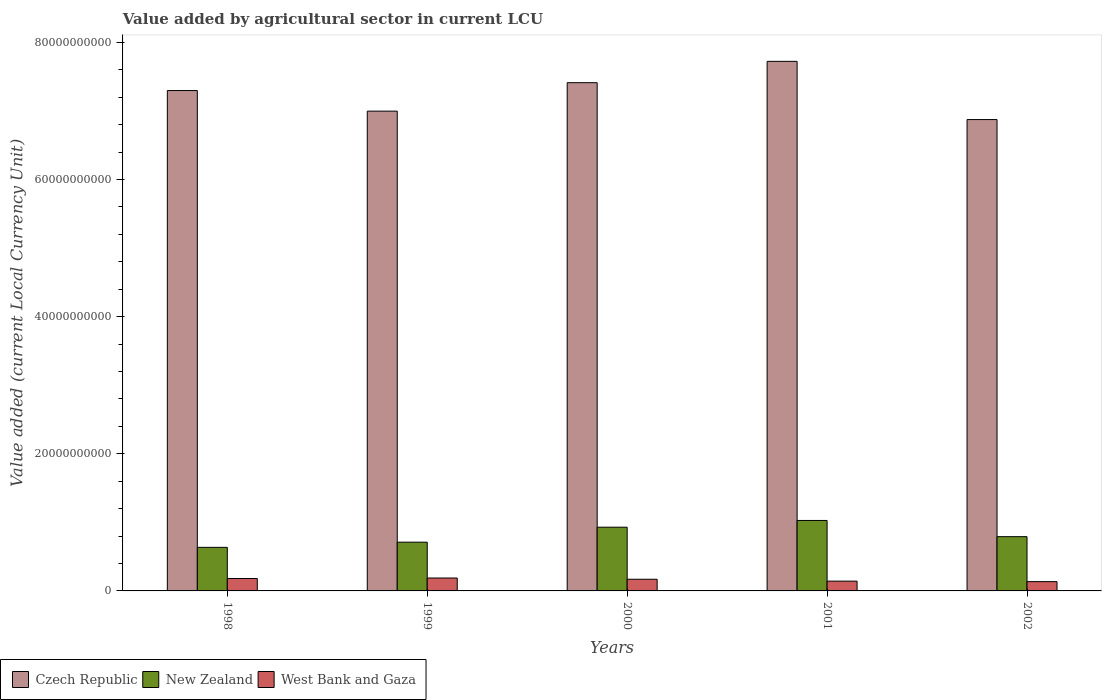Are the number of bars on each tick of the X-axis equal?
Provide a short and direct response. Yes. How many bars are there on the 3rd tick from the left?
Ensure brevity in your answer.  3. What is the label of the 1st group of bars from the left?
Keep it short and to the point. 1998. In how many cases, is the number of bars for a given year not equal to the number of legend labels?
Your answer should be compact. 0. What is the value added by agricultural sector in New Zealand in 2002?
Your answer should be very brief. 7.91e+09. Across all years, what is the maximum value added by agricultural sector in New Zealand?
Keep it short and to the point. 1.03e+1. Across all years, what is the minimum value added by agricultural sector in West Bank and Gaza?
Provide a short and direct response. 1.35e+09. What is the total value added by agricultural sector in Czech Republic in the graph?
Offer a very short reply. 3.63e+11. What is the difference between the value added by agricultural sector in Czech Republic in 1998 and that in 2002?
Offer a very short reply. 4.23e+09. What is the difference between the value added by agricultural sector in West Bank and Gaza in 2000 and the value added by agricultural sector in Czech Republic in 2002?
Provide a succinct answer. -6.70e+1. What is the average value added by agricultural sector in West Bank and Gaza per year?
Your response must be concise. 1.64e+09. In the year 2002, what is the difference between the value added by agricultural sector in New Zealand and value added by agricultural sector in Czech Republic?
Provide a succinct answer. -6.08e+1. What is the ratio of the value added by agricultural sector in New Zealand in 2000 to that in 2002?
Keep it short and to the point. 1.17. Is the difference between the value added by agricultural sector in New Zealand in 2000 and 2001 greater than the difference between the value added by agricultural sector in Czech Republic in 2000 and 2001?
Give a very brief answer. Yes. What is the difference between the highest and the second highest value added by agricultural sector in Czech Republic?
Give a very brief answer. 3.11e+09. What is the difference between the highest and the lowest value added by agricultural sector in New Zealand?
Your answer should be very brief. 3.92e+09. In how many years, is the value added by agricultural sector in Czech Republic greater than the average value added by agricultural sector in Czech Republic taken over all years?
Ensure brevity in your answer.  3. What does the 2nd bar from the left in 1998 represents?
Your response must be concise. New Zealand. What does the 3rd bar from the right in 2000 represents?
Give a very brief answer. Czech Republic. Is it the case that in every year, the sum of the value added by agricultural sector in Czech Republic and value added by agricultural sector in West Bank and Gaza is greater than the value added by agricultural sector in New Zealand?
Provide a short and direct response. Yes. How many bars are there?
Make the answer very short. 15. Are the values on the major ticks of Y-axis written in scientific E-notation?
Keep it short and to the point. No. Does the graph contain any zero values?
Keep it short and to the point. No. How many legend labels are there?
Your response must be concise. 3. What is the title of the graph?
Make the answer very short. Value added by agricultural sector in current LCU. Does "Iran" appear as one of the legend labels in the graph?
Offer a very short reply. No. What is the label or title of the Y-axis?
Your answer should be very brief. Value added (current Local Currency Unit). What is the Value added (current Local Currency Unit) in Czech Republic in 1998?
Provide a short and direct response. 7.30e+1. What is the Value added (current Local Currency Unit) in New Zealand in 1998?
Keep it short and to the point. 6.35e+09. What is the Value added (current Local Currency Unit) of West Bank and Gaza in 1998?
Your response must be concise. 1.81e+09. What is the Value added (current Local Currency Unit) of Czech Republic in 1999?
Make the answer very short. 7.00e+1. What is the Value added (current Local Currency Unit) of New Zealand in 1999?
Your answer should be compact. 7.11e+09. What is the Value added (current Local Currency Unit) of West Bank and Gaza in 1999?
Provide a short and direct response. 1.88e+09. What is the Value added (current Local Currency Unit) of Czech Republic in 2000?
Make the answer very short. 7.41e+1. What is the Value added (current Local Currency Unit) of New Zealand in 2000?
Provide a short and direct response. 9.29e+09. What is the Value added (current Local Currency Unit) of West Bank and Gaza in 2000?
Offer a very short reply. 1.70e+09. What is the Value added (current Local Currency Unit) in Czech Republic in 2001?
Provide a short and direct response. 7.72e+1. What is the Value added (current Local Currency Unit) in New Zealand in 2001?
Make the answer very short. 1.03e+1. What is the Value added (current Local Currency Unit) in West Bank and Gaza in 2001?
Offer a terse response. 1.43e+09. What is the Value added (current Local Currency Unit) of Czech Republic in 2002?
Keep it short and to the point. 6.87e+1. What is the Value added (current Local Currency Unit) in New Zealand in 2002?
Provide a short and direct response. 7.91e+09. What is the Value added (current Local Currency Unit) in West Bank and Gaza in 2002?
Provide a succinct answer. 1.35e+09. Across all years, what is the maximum Value added (current Local Currency Unit) in Czech Republic?
Keep it short and to the point. 7.72e+1. Across all years, what is the maximum Value added (current Local Currency Unit) of New Zealand?
Make the answer very short. 1.03e+1. Across all years, what is the maximum Value added (current Local Currency Unit) of West Bank and Gaza?
Your response must be concise. 1.88e+09. Across all years, what is the minimum Value added (current Local Currency Unit) in Czech Republic?
Provide a succinct answer. 6.87e+1. Across all years, what is the minimum Value added (current Local Currency Unit) in New Zealand?
Provide a short and direct response. 6.35e+09. Across all years, what is the minimum Value added (current Local Currency Unit) in West Bank and Gaza?
Give a very brief answer. 1.35e+09. What is the total Value added (current Local Currency Unit) in Czech Republic in the graph?
Ensure brevity in your answer.  3.63e+11. What is the total Value added (current Local Currency Unit) of New Zealand in the graph?
Give a very brief answer. 4.09e+1. What is the total Value added (current Local Currency Unit) in West Bank and Gaza in the graph?
Make the answer very short. 8.18e+09. What is the difference between the Value added (current Local Currency Unit) of Czech Republic in 1998 and that in 1999?
Your answer should be compact. 3.00e+09. What is the difference between the Value added (current Local Currency Unit) of New Zealand in 1998 and that in 1999?
Make the answer very short. -7.54e+08. What is the difference between the Value added (current Local Currency Unit) of West Bank and Gaza in 1998 and that in 1999?
Provide a short and direct response. -7.26e+07. What is the difference between the Value added (current Local Currency Unit) of Czech Republic in 1998 and that in 2000?
Your answer should be very brief. -1.15e+09. What is the difference between the Value added (current Local Currency Unit) in New Zealand in 1998 and that in 2000?
Provide a short and direct response. -2.94e+09. What is the difference between the Value added (current Local Currency Unit) of West Bank and Gaza in 1998 and that in 2000?
Give a very brief answer. 1.07e+08. What is the difference between the Value added (current Local Currency Unit) in Czech Republic in 1998 and that in 2001?
Your answer should be compact. -4.26e+09. What is the difference between the Value added (current Local Currency Unit) in New Zealand in 1998 and that in 2001?
Your answer should be compact. -3.92e+09. What is the difference between the Value added (current Local Currency Unit) in West Bank and Gaza in 1998 and that in 2001?
Your response must be concise. 3.83e+08. What is the difference between the Value added (current Local Currency Unit) of Czech Republic in 1998 and that in 2002?
Make the answer very short. 4.23e+09. What is the difference between the Value added (current Local Currency Unit) in New Zealand in 1998 and that in 2002?
Make the answer very short. -1.56e+09. What is the difference between the Value added (current Local Currency Unit) of West Bank and Gaza in 1998 and that in 2002?
Your response must be concise. 4.57e+08. What is the difference between the Value added (current Local Currency Unit) of Czech Republic in 1999 and that in 2000?
Provide a succinct answer. -4.15e+09. What is the difference between the Value added (current Local Currency Unit) in New Zealand in 1999 and that in 2000?
Your answer should be very brief. -2.18e+09. What is the difference between the Value added (current Local Currency Unit) of West Bank and Gaza in 1999 and that in 2000?
Offer a very short reply. 1.79e+08. What is the difference between the Value added (current Local Currency Unit) of Czech Republic in 1999 and that in 2001?
Ensure brevity in your answer.  -7.26e+09. What is the difference between the Value added (current Local Currency Unit) of New Zealand in 1999 and that in 2001?
Make the answer very short. -3.17e+09. What is the difference between the Value added (current Local Currency Unit) of West Bank and Gaza in 1999 and that in 2001?
Offer a very short reply. 4.55e+08. What is the difference between the Value added (current Local Currency Unit) in Czech Republic in 1999 and that in 2002?
Give a very brief answer. 1.23e+09. What is the difference between the Value added (current Local Currency Unit) of New Zealand in 1999 and that in 2002?
Ensure brevity in your answer.  -8.06e+08. What is the difference between the Value added (current Local Currency Unit) of West Bank and Gaza in 1999 and that in 2002?
Your response must be concise. 5.30e+08. What is the difference between the Value added (current Local Currency Unit) in Czech Republic in 2000 and that in 2001?
Your answer should be very brief. -3.11e+09. What is the difference between the Value added (current Local Currency Unit) of New Zealand in 2000 and that in 2001?
Provide a short and direct response. -9.82e+08. What is the difference between the Value added (current Local Currency Unit) in West Bank and Gaza in 2000 and that in 2001?
Offer a terse response. 2.76e+08. What is the difference between the Value added (current Local Currency Unit) of Czech Republic in 2000 and that in 2002?
Provide a succinct answer. 5.38e+09. What is the difference between the Value added (current Local Currency Unit) of New Zealand in 2000 and that in 2002?
Give a very brief answer. 1.38e+09. What is the difference between the Value added (current Local Currency Unit) of West Bank and Gaza in 2000 and that in 2002?
Provide a succinct answer. 3.50e+08. What is the difference between the Value added (current Local Currency Unit) in Czech Republic in 2001 and that in 2002?
Offer a terse response. 8.49e+09. What is the difference between the Value added (current Local Currency Unit) in New Zealand in 2001 and that in 2002?
Your answer should be compact. 2.36e+09. What is the difference between the Value added (current Local Currency Unit) in West Bank and Gaza in 2001 and that in 2002?
Your response must be concise. 7.43e+07. What is the difference between the Value added (current Local Currency Unit) of Czech Republic in 1998 and the Value added (current Local Currency Unit) of New Zealand in 1999?
Provide a short and direct response. 6.59e+1. What is the difference between the Value added (current Local Currency Unit) in Czech Republic in 1998 and the Value added (current Local Currency Unit) in West Bank and Gaza in 1999?
Give a very brief answer. 7.11e+1. What is the difference between the Value added (current Local Currency Unit) of New Zealand in 1998 and the Value added (current Local Currency Unit) of West Bank and Gaza in 1999?
Give a very brief answer. 4.47e+09. What is the difference between the Value added (current Local Currency Unit) in Czech Republic in 1998 and the Value added (current Local Currency Unit) in New Zealand in 2000?
Your response must be concise. 6.37e+1. What is the difference between the Value added (current Local Currency Unit) in Czech Republic in 1998 and the Value added (current Local Currency Unit) in West Bank and Gaza in 2000?
Offer a very short reply. 7.13e+1. What is the difference between the Value added (current Local Currency Unit) in New Zealand in 1998 and the Value added (current Local Currency Unit) in West Bank and Gaza in 2000?
Offer a terse response. 4.65e+09. What is the difference between the Value added (current Local Currency Unit) in Czech Republic in 1998 and the Value added (current Local Currency Unit) in New Zealand in 2001?
Offer a terse response. 6.27e+1. What is the difference between the Value added (current Local Currency Unit) of Czech Republic in 1998 and the Value added (current Local Currency Unit) of West Bank and Gaza in 2001?
Ensure brevity in your answer.  7.15e+1. What is the difference between the Value added (current Local Currency Unit) of New Zealand in 1998 and the Value added (current Local Currency Unit) of West Bank and Gaza in 2001?
Offer a very short reply. 4.92e+09. What is the difference between the Value added (current Local Currency Unit) in Czech Republic in 1998 and the Value added (current Local Currency Unit) in New Zealand in 2002?
Provide a short and direct response. 6.50e+1. What is the difference between the Value added (current Local Currency Unit) in Czech Republic in 1998 and the Value added (current Local Currency Unit) in West Bank and Gaza in 2002?
Your response must be concise. 7.16e+1. What is the difference between the Value added (current Local Currency Unit) of New Zealand in 1998 and the Value added (current Local Currency Unit) of West Bank and Gaza in 2002?
Offer a very short reply. 5.00e+09. What is the difference between the Value added (current Local Currency Unit) in Czech Republic in 1999 and the Value added (current Local Currency Unit) in New Zealand in 2000?
Give a very brief answer. 6.07e+1. What is the difference between the Value added (current Local Currency Unit) of Czech Republic in 1999 and the Value added (current Local Currency Unit) of West Bank and Gaza in 2000?
Provide a short and direct response. 6.83e+1. What is the difference between the Value added (current Local Currency Unit) in New Zealand in 1999 and the Value added (current Local Currency Unit) in West Bank and Gaza in 2000?
Provide a succinct answer. 5.40e+09. What is the difference between the Value added (current Local Currency Unit) of Czech Republic in 1999 and the Value added (current Local Currency Unit) of New Zealand in 2001?
Your answer should be very brief. 5.97e+1. What is the difference between the Value added (current Local Currency Unit) in Czech Republic in 1999 and the Value added (current Local Currency Unit) in West Bank and Gaza in 2001?
Offer a very short reply. 6.85e+1. What is the difference between the Value added (current Local Currency Unit) in New Zealand in 1999 and the Value added (current Local Currency Unit) in West Bank and Gaza in 2001?
Your response must be concise. 5.68e+09. What is the difference between the Value added (current Local Currency Unit) in Czech Republic in 1999 and the Value added (current Local Currency Unit) in New Zealand in 2002?
Your answer should be very brief. 6.20e+1. What is the difference between the Value added (current Local Currency Unit) of Czech Republic in 1999 and the Value added (current Local Currency Unit) of West Bank and Gaza in 2002?
Make the answer very short. 6.86e+1. What is the difference between the Value added (current Local Currency Unit) in New Zealand in 1999 and the Value added (current Local Currency Unit) in West Bank and Gaza in 2002?
Make the answer very short. 5.75e+09. What is the difference between the Value added (current Local Currency Unit) of Czech Republic in 2000 and the Value added (current Local Currency Unit) of New Zealand in 2001?
Make the answer very short. 6.38e+1. What is the difference between the Value added (current Local Currency Unit) of Czech Republic in 2000 and the Value added (current Local Currency Unit) of West Bank and Gaza in 2001?
Your answer should be compact. 7.27e+1. What is the difference between the Value added (current Local Currency Unit) in New Zealand in 2000 and the Value added (current Local Currency Unit) in West Bank and Gaza in 2001?
Your answer should be compact. 7.86e+09. What is the difference between the Value added (current Local Currency Unit) of Czech Republic in 2000 and the Value added (current Local Currency Unit) of New Zealand in 2002?
Offer a terse response. 6.62e+1. What is the difference between the Value added (current Local Currency Unit) of Czech Republic in 2000 and the Value added (current Local Currency Unit) of West Bank and Gaza in 2002?
Provide a short and direct response. 7.28e+1. What is the difference between the Value added (current Local Currency Unit) of New Zealand in 2000 and the Value added (current Local Currency Unit) of West Bank and Gaza in 2002?
Provide a short and direct response. 7.94e+09. What is the difference between the Value added (current Local Currency Unit) of Czech Republic in 2001 and the Value added (current Local Currency Unit) of New Zealand in 2002?
Give a very brief answer. 6.93e+1. What is the difference between the Value added (current Local Currency Unit) of Czech Republic in 2001 and the Value added (current Local Currency Unit) of West Bank and Gaza in 2002?
Your response must be concise. 7.59e+1. What is the difference between the Value added (current Local Currency Unit) of New Zealand in 2001 and the Value added (current Local Currency Unit) of West Bank and Gaza in 2002?
Offer a terse response. 8.92e+09. What is the average Value added (current Local Currency Unit) in Czech Republic per year?
Make the answer very short. 7.26e+1. What is the average Value added (current Local Currency Unit) of New Zealand per year?
Ensure brevity in your answer.  8.19e+09. What is the average Value added (current Local Currency Unit) in West Bank and Gaza per year?
Your answer should be compact. 1.64e+09. In the year 1998, what is the difference between the Value added (current Local Currency Unit) in Czech Republic and Value added (current Local Currency Unit) in New Zealand?
Your answer should be very brief. 6.66e+1. In the year 1998, what is the difference between the Value added (current Local Currency Unit) in Czech Republic and Value added (current Local Currency Unit) in West Bank and Gaza?
Your answer should be very brief. 7.12e+1. In the year 1998, what is the difference between the Value added (current Local Currency Unit) of New Zealand and Value added (current Local Currency Unit) of West Bank and Gaza?
Your response must be concise. 4.54e+09. In the year 1999, what is the difference between the Value added (current Local Currency Unit) of Czech Republic and Value added (current Local Currency Unit) of New Zealand?
Provide a short and direct response. 6.29e+1. In the year 1999, what is the difference between the Value added (current Local Currency Unit) of Czech Republic and Value added (current Local Currency Unit) of West Bank and Gaza?
Offer a very short reply. 6.81e+1. In the year 1999, what is the difference between the Value added (current Local Currency Unit) of New Zealand and Value added (current Local Currency Unit) of West Bank and Gaza?
Offer a very short reply. 5.22e+09. In the year 2000, what is the difference between the Value added (current Local Currency Unit) of Czech Republic and Value added (current Local Currency Unit) of New Zealand?
Provide a succinct answer. 6.48e+1. In the year 2000, what is the difference between the Value added (current Local Currency Unit) in Czech Republic and Value added (current Local Currency Unit) in West Bank and Gaza?
Your answer should be very brief. 7.24e+1. In the year 2000, what is the difference between the Value added (current Local Currency Unit) in New Zealand and Value added (current Local Currency Unit) in West Bank and Gaza?
Your answer should be compact. 7.59e+09. In the year 2001, what is the difference between the Value added (current Local Currency Unit) of Czech Republic and Value added (current Local Currency Unit) of New Zealand?
Your answer should be compact. 6.69e+1. In the year 2001, what is the difference between the Value added (current Local Currency Unit) in Czech Republic and Value added (current Local Currency Unit) in West Bank and Gaza?
Your answer should be very brief. 7.58e+1. In the year 2001, what is the difference between the Value added (current Local Currency Unit) of New Zealand and Value added (current Local Currency Unit) of West Bank and Gaza?
Ensure brevity in your answer.  8.85e+09. In the year 2002, what is the difference between the Value added (current Local Currency Unit) of Czech Republic and Value added (current Local Currency Unit) of New Zealand?
Your answer should be compact. 6.08e+1. In the year 2002, what is the difference between the Value added (current Local Currency Unit) in Czech Republic and Value added (current Local Currency Unit) in West Bank and Gaza?
Provide a short and direct response. 6.74e+1. In the year 2002, what is the difference between the Value added (current Local Currency Unit) of New Zealand and Value added (current Local Currency Unit) of West Bank and Gaza?
Ensure brevity in your answer.  6.56e+09. What is the ratio of the Value added (current Local Currency Unit) of Czech Republic in 1998 to that in 1999?
Make the answer very short. 1.04. What is the ratio of the Value added (current Local Currency Unit) of New Zealand in 1998 to that in 1999?
Provide a short and direct response. 0.89. What is the ratio of the Value added (current Local Currency Unit) in West Bank and Gaza in 1998 to that in 1999?
Make the answer very short. 0.96. What is the ratio of the Value added (current Local Currency Unit) in Czech Republic in 1998 to that in 2000?
Your answer should be very brief. 0.98. What is the ratio of the Value added (current Local Currency Unit) of New Zealand in 1998 to that in 2000?
Make the answer very short. 0.68. What is the ratio of the Value added (current Local Currency Unit) in West Bank and Gaza in 1998 to that in 2000?
Offer a very short reply. 1.06. What is the ratio of the Value added (current Local Currency Unit) in Czech Republic in 1998 to that in 2001?
Provide a short and direct response. 0.94. What is the ratio of the Value added (current Local Currency Unit) in New Zealand in 1998 to that in 2001?
Your answer should be very brief. 0.62. What is the ratio of the Value added (current Local Currency Unit) in West Bank and Gaza in 1998 to that in 2001?
Provide a succinct answer. 1.27. What is the ratio of the Value added (current Local Currency Unit) of Czech Republic in 1998 to that in 2002?
Your response must be concise. 1.06. What is the ratio of the Value added (current Local Currency Unit) of New Zealand in 1998 to that in 2002?
Give a very brief answer. 0.8. What is the ratio of the Value added (current Local Currency Unit) of West Bank and Gaza in 1998 to that in 2002?
Provide a succinct answer. 1.34. What is the ratio of the Value added (current Local Currency Unit) in Czech Republic in 1999 to that in 2000?
Your answer should be compact. 0.94. What is the ratio of the Value added (current Local Currency Unit) of New Zealand in 1999 to that in 2000?
Your answer should be very brief. 0.76. What is the ratio of the Value added (current Local Currency Unit) of West Bank and Gaza in 1999 to that in 2000?
Your answer should be compact. 1.11. What is the ratio of the Value added (current Local Currency Unit) in Czech Republic in 1999 to that in 2001?
Provide a short and direct response. 0.91. What is the ratio of the Value added (current Local Currency Unit) in New Zealand in 1999 to that in 2001?
Ensure brevity in your answer.  0.69. What is the ratio of the Value added (current Local Currency Unit) of West Bank and Gaza in 1999 to that in 2001?
Make the answer very short. 1.32. What is the ratio of the Value added (current Local Currency Unit) in Czech Republic in 1999 to that in 2002?
Offer a very short reply. 1.02. What is the ratio of the Value added (current Local Currency Unit) of New Zealand in 1999 to that in 2002?
Make the answer very short. 0.9. What is the ratio of the Value added (current Local Currency Unit) in West Bank and Gaza in 1999 to that in 2002?
Give a very brief answer. 1.39. What is the ratio of the Value added (current Local Currency Unit) of Czech Republic in 2000 to that in 2001?
Give a very brief answer. 0.96. What is the ratio of the Value added (current Local Currency Unit) of New Zealand in 2000 to that in 2001?
Your answer should be compact. 0.9. What is the ratio of the Value added (current Local Currency Unit) in West Bank and Gaza in 2000 to that in 2001?
Your answer should be compact. 1.19. What is the ratio of the Value added (current Local Currency Unit) of Czech Republic in 2000 to that in 2002?
Make the answer very short. 1.08. What is the ratio of the Value added (current Local Currency Unit) in New Zealand in 2000 to that in 2002?
Ensure brevity in your answer.  1.17. What is the ratio of the Value added (current Local Currency Unit) of West Bank and Gaza in 2000 to that in 2002?
Provide a succinct answer. 1.26. What is the ratio of the Value added (current Local Currency Unit) in Czech Republic in 2001 to that in 2002?
Offer a terse response. 1.12. What is the ratio of the Value added (current Local Currency Unit) in New Zealand in 2001 to that in 2002?
Ensure brevity in your answer.  1.3. What is the ratio of the Value added (current Local Currency Unit) in West Bank and Gaza in 2001 to that in 2002?
Your answer should be very brief. 1.05. What is the difference between the highest and the second highest Value added (current Local Currency Unit) in Czech Republic?
Offer a very short reply. 3.11e+09. What is the difference between the highest and the second highest Value added (current Local Currency Unit) of New Zealand?
Ensure brevity in your answer.  9.82e+08. What is the difference between the highest and the second highest Value added (current Local Currency Unit) of West Bank and Gaza?
Your response must be concise. 7.26e+07. What is the difference between the highest and the lowest Value added (current Local Currency Unit) of Czech Republic?
Make the answer very short. 8.49e+09. What is the difference between the highest and the lowest Value added (current Local Currency Unit) in New Zealand?
Ensure brevity in your answer.  3.92e+09. What is the difference between the highest and the lowest Value added (current Local Currency Unit) of West Bank and Gaza?
Offer a terse response. 5.30e+08. 